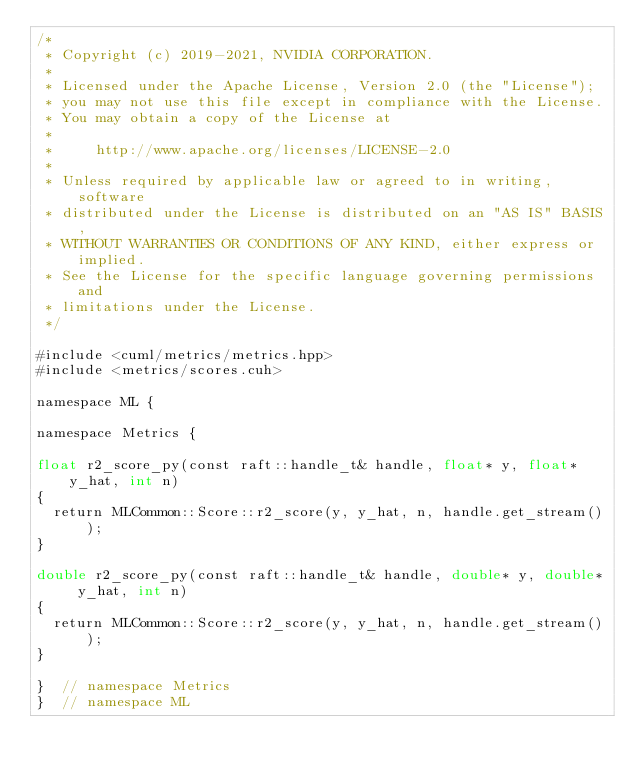<code> <loc_0><loc_0><loc_500><loc_500><_Cuda_>/*
 * Copyright (c) 2019-2021, NVIDIA CORPORATION.
 *
 * Licensed under the Apache License, Version 2.0 (the "License");
 * you may not use this file except in compliance with the License.
 * You may obtain a copy of the License at
 *
 *     http://www.apache.org/licenses/LICENSE-2.0
 *
 * Unless required by applicable law or agreed to in writing, software
 * distributed under the License is distributed on an "AS IS" BASIS,
 * WITHOUT WARRANTIES OR CONDITIONS OF ANY KIND, either express or implied.
 * See the License for the specific language governing permissions and
 * limitations under the License.
 */

#include <cuml/metrics/metrics.hpp>
#include <metrics/scores.cuh>

namespace ML {

namespace Metrics {

float r2_score_py(const raft::handle_t& handle, float* y, float* y_hat, int n)
{
  return MLCommon::Score::r2_score(y, y_hat, n, handle.get_stream());
}

double r2_score_py(const raft::handle_t& handle, double* y, double* y_hat, int n)
{
  return MLCommon::Score::r2_score(y, y_hat, n, handle.get_stream());
}

}  // namespace Metrics
}  // namespace ML
</code> 